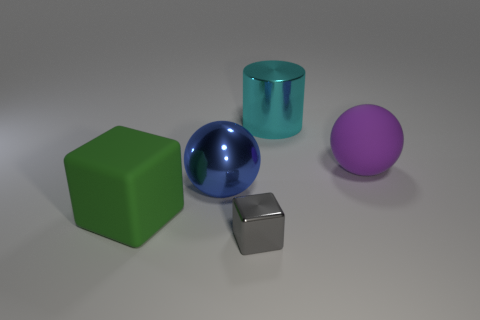Add 1 shiny things. How many objects exist? 6 Subtract all cylinders. How many objects are left? 4 Add 1 large things. How many large things exist? 5 Subtract 0 red cylinders. How many objects are left? 5 Subtract all big brown rubber blocks. Subtract all big purple balls. How many objects are left? 4 Add 3 big shiny spheres. How many big shiny spheres are left? 4 